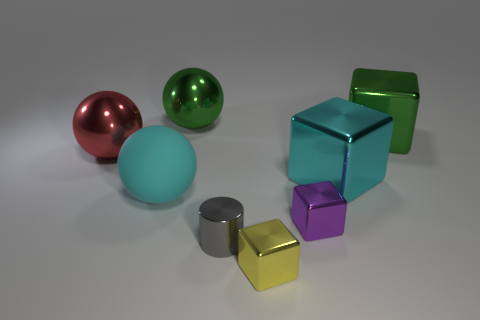Subtract 1 cubes. How many cubes are left? 3 Add 1 big red things. How many objects exist? 9 Subtract all spheres. How many objects are left? 5 Add 3 red metallic spheres. How many red metallic spheres exist? 4 Subtract 0 cyan cylinders. How many objects are left? 8 Subtract all yellow metal cylinders. Subtract all cyan metal blocks. How many objects are left? 7 Add 1 big green things. How many big green things are left? 3 